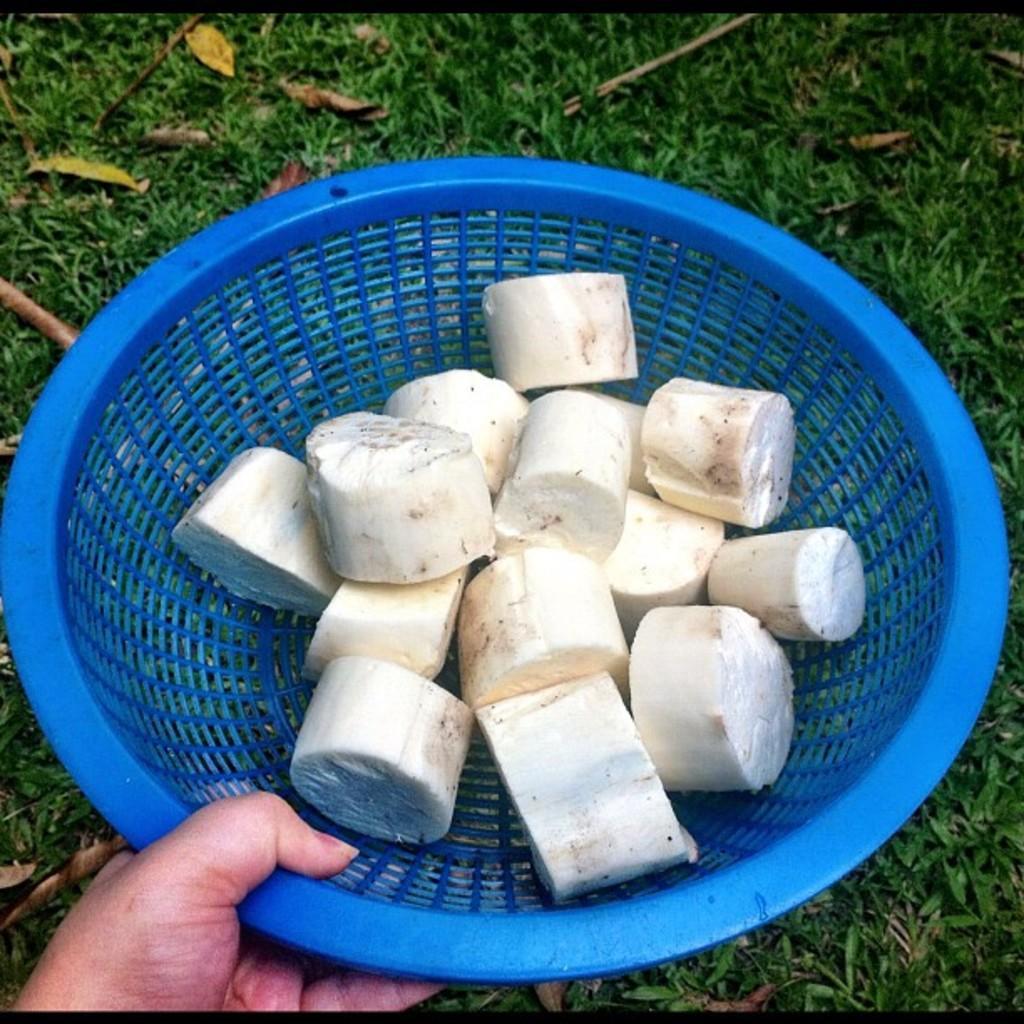Describe this image in one or two sentences. In this image I can see the person holding the basket and I can see the food in the basket. In the background the grass is in green color. 